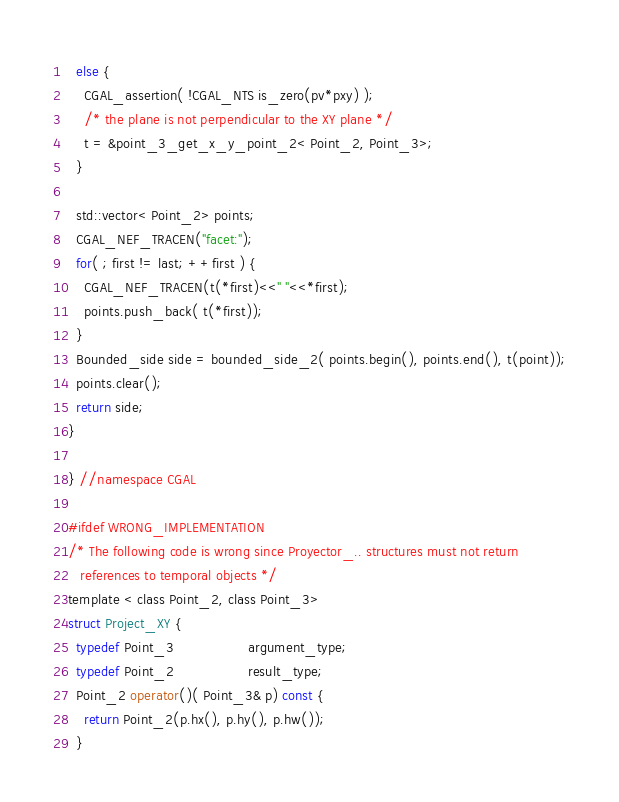Convert code to text. <code><loc_0><loc_0><loc_500><loc_500><_C_>  else {
    CGAL_assertion( !CGAL_NTS is_zero(pv*pxy) );
    /* the plane is not perpendicular to the XY plane */
    t = &point_3_get_x_y_point_2< Point_2, Point_3>;
  }

  std::vector< Point_2> points;
  CGAL_NEF_TRACEN("facet:");
  for( ; first != last; ++first ) {
    CGAL_NEF_TRACEN(t(*first)<<" "<<*first);
    points.push_back( t(*first));
  }
  Bounded_side side = bounded_side_2( points.begin(), points.end(), t(point));
  points.clear();
  return side;
}

} //namespace CGAL

#ifdef WRONG_IMPLEMENTATION
/* The following code is wrong since Proyector_.. structures must not return
   references to temporal objects */
template < class Point_2, class Point_3>
struct Project_XY {
  typedef Point_3                  argument_type;
  typedef Point_2                  result_type;
  Point_2 operator()( Point_3& p) const {
    return Point_2(p.hx(), p.hy(), p.hw());
  }</code> 